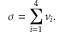Convert formula to latex. <formula><loc_0><loc_0><loc_500><loc_500>\sigma = \sum _ { i = 1 } ^ { 4 } \nu _ { i } .</formula> 